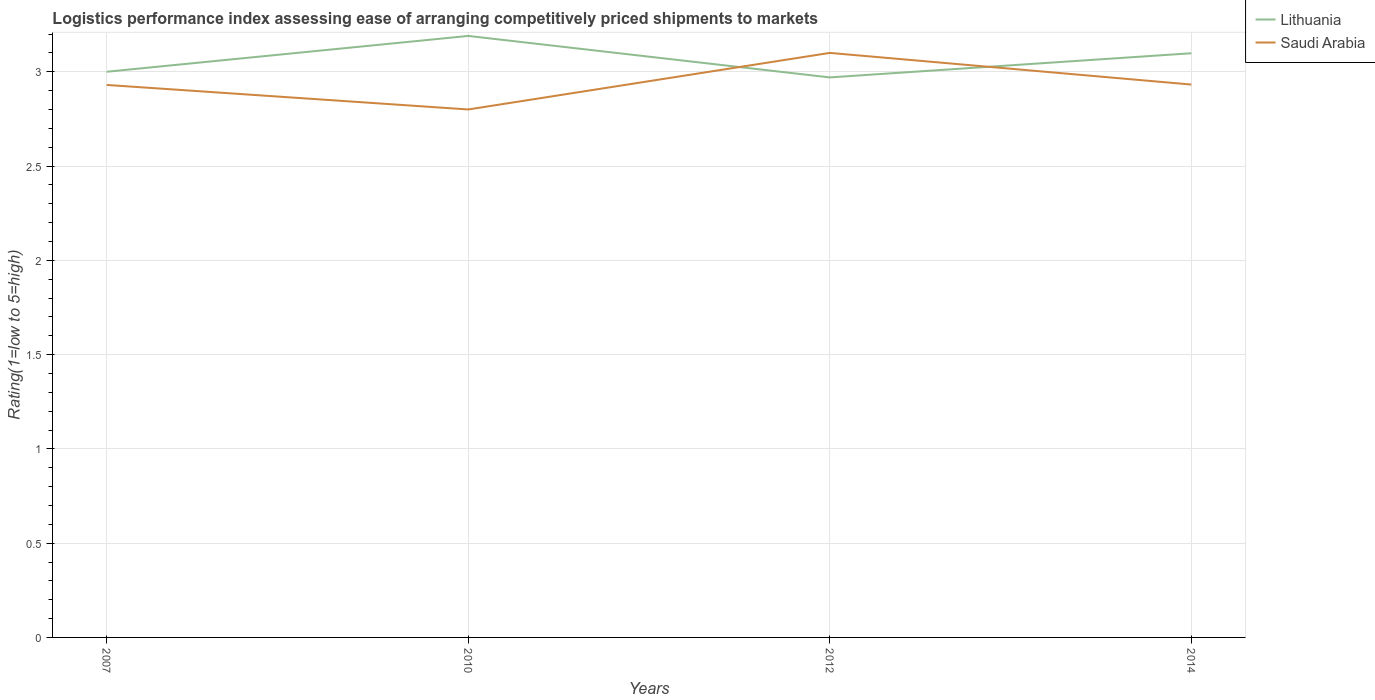In which year was the Logistic performance index in Lithuania maximum?
Offer a terse response. 2012. What is the total Logistic performance index in Saudi Arabia in the graph?
Offer a terse response. -0.17. What is the difference between the highest and the second highest Logistic performance index in Saudi Arabia?
Your answer should be compact. 0.3. Is the Logistic performance index in Lithuania strictly greater than the Logistic performance index in Saudi Arabia over the years?
Provide a short and direct response. No. How many years are there in the graph?
Ensure brevity in your answer.  4. What is the difference between two consecutive major ticks on the Y-axis?
Give a very brief answer. 0.5. Does the graph contain any zero values?
Provide a succinct answer. No. Where does the legend appear in the graph?
Your answer should be very brief. Top right. How many legend labels are there?
Your answer should be compact. 2. How are the legend labels stacked?
Provide a short and direct response. Vertical. What is the title of the graph?
Ensure brevity in your answer.  Logistics performance index assessing ease of arranging competitively priced shipments to markets. What is the label or title of the Y-axis?
Ensure brevity in your answer.  Rating(1=low to 5=high). What is the Rating(1=low to 5=high) in Lithuania in 2007?
Offer a terse response. 3. What is the Rating(1=low to 5=high) of Saudi Arabia in 2007?
Keep it short and to the point. 2.93. What is the Rating(1=low to 5=high) in Lithuania in 2010?
Your response must be concise. 3.19. What is the Rating(1=low to 5=high) in Saudi Arabia in 2010?
Your response must be concise. 2.8. What is the Rating(1=low to 5=high) in Lithuania in 2012?
Keep it short and to the point. 2.97. What is the Rating(1=low to 5=high) in Lithuania in 2014?
Provide a succinct answer. 3.1. What is the Rating(1=low to 5=high) of Saudi Arabia in 2014?
Provide a short and direct response. 2.93. Across all years, what is the maximum Rating(1=low to 5=high) of Lithuania?
Provide a succinct answer. 3.19. Across all years, what is the minimum Rating(1=low to 5=high) in Lithuania?
Your answer should be very brief. 2.97. Across all years, what is the minimum Rating(1=low to 5=high) of Saudi Arabia?
Keep it short and to the point. 2.8. What is the total Rating(1=low to 5=high) in Lithuania in the graph?
Offer a very short reply. 12.26. What is the total Rating(1=low to 5=high) in Saudi Arabia in the graph?
Offer a terse response. 11.76. What is the difference between the Rating(1=low to 5=high) of Lithuania in 2007 and that in 2010?
Your answer should be very brief. -0.19. What is the difference between the Rating(1=low to 5=high) of Saudi Arabia in 2007 and that in 2010?
Offer a terse response. 0.13. What is the difference between the Rating(1=low to 5=high) in Saudi Arabia in 2007 and that in 2012?
Provide a short and direct response. -0.17. What is the difference between the Rating(1=low to 5=high) in Lithuania in 2007 and that in 2014?
Offer a very short reply. -0.1. What is the difference between the Rating(1=low to 5=high) of Saudi Arabia in 2007 and that in 2014?
Your answer should be compact. -0. What is the difference between the Rating(1=low to 5=high) of Lithuania in 2010 and that in 2012?
Give a very brief answer. 0.22. What is the difference between the Rating(1=low to 5=high) in Saudi Arabia in 2010 and that in 2012?
Your response must be concise. -0.3. What is the difference between the Rating(1=low to 5=high) in Lithuania in 2010 and that in 2014?
Offer a terse response. 0.09. What is the difference between the Rating(1=low to 5=high) of Saudi Arabia in 2010 and that in 2014?
Offer a terse response. -0.13. What is the difference between the Rating(1=low to 5=high) in Lithuania in 2012 and that in 2014?
Your answer should be compact. -0.13. What is the difference between the Rating(1=low to 5=high) in Saudi Arabia in 2012 and that in 2014?
Offer a very short reply. 0.17. What is the difference between the Rating(1=low to 5=high) of Lithuania in 2007 and the Rating(1=low to 5=high) of Saudi Arabia in 2012?
Give a very brief answer. -0.1. What is the difference between the Rating(1=low to 5=high) of Lithuania in 2007 and the Rating(1=low to 5=high) of Saudi Arabia in 2014?
Offer a very short reply. 0.07. What is the difference between the Rating(1=low to 5=high) in Lithuania in 2010 and the Rating(1=low to 5=high) in Saudi Arabia in 2012?
Your response must be concise. 0.09. What is the difference between the Rating(1=low to 5=high) of Lithuania in 2010 and the Rating(1=low to 5=high) of Saudi Arabia in 2014?
Provide a short and direct response. 0.26. What is the difference between the Rating(1=low to 5=high) of Lithuania in 2012 and the Rating(1=low to 5=high) of Saudi Arabia in 2014?
Give a very brief answer. 0.04. What is the average Rating(1=low to 5=high) of Lithuania per year?
Your answer should be compact. 3.06. What is the average Rating(1=low to 5=high) of Saudi Arabia per year?
Your response must be concise. 2.94. In the year 2007, what is the difference between the Rating(1=low to 5=high) in Lithuania and Rating(1=low to 5=high) in Saudi Arabia?
Your response must be concise. 0.07. In the year 2010, what is the difference between the Rating(1=low to 5=high) of Lithuania and Rating(1=low to 5=high) of Saudi Arabia?
Your answer should be compact. 0.39. In the year 2012, what is the difference between the Rating(1=low to 5=high) in Lithuania and Rating(1=low to 5=high) in Saudi Arabia?
Provide a short and direct response. -0.13. In the year 2014, what is the difference between the Rating(1=low to 5=high) in Lithuania and Rating(1=low to 5=high) in Saudi Arabia?
Give a very brief answer. 0.17. What is the ratio of the Rating(1=low to 5=high) in Lithuania in 2007 to that in 2010?
Provide a succinct answer. 0.94. What is the ratio of the Rating(1=low to 5=high) of Saudi Arabia in 2007 to that in 2010?
Provide a short and direct response. 1.05. What is the ratio of the Rating(1=low to 5=high) of Saudi Arabia in 2007 to that in 2012?
Offer a very short reply. 0.95. What is the ratio of the Rating(1=low to 5=high) of Lithuania in 2007 to that in 2014?
Your response must be concise. 0.97. What is the ratio of the Rating(1=low to 5=high) in Saudi Arabia in 2007 to that in 2014?
Give a very brief answer. 1. What is the ratio of the Rating(1=low to 5=high) of Lithuania in 2010 to that in 2012?
Offer a terse response. 1.07. What is the ratio of the Rating(1=low to 5=high) of Saudi Arabia in 2010 to that in 2012?
Keep it short and to the point. 0.9. What is the ratio of the Rating(1=low to 5=high) of Lithuania in 2010 to that in 2014?
Make the answer very short. 1.03. What is the ratio of the Rating(1=low to 5=high) of Saudi Arabia in 2010 to that in 2014?
Ensure brevity in your answer.  0.95. What is the ratio of the Rating(1=low to 5=high) of Lithuania in 2012 to that in 2014?
Ensure brevity in your answer.  0.96. What is the ratio of the Rating(1=low to 5=high) of Saudi Arabia in 2012 to that in 2014?
Make the answer very short. 1.06. What is the difference between the highest and the second highest Rating(1=low to 5=high) in Lithuania?
Provide a succinct answer. 0.09. What is the difference between the highest and the second highest Rating(1=low to 5=high) of Saudi Arabia?
Provide a succinct answer. 0.17. What is the difference between the highest and the lowest Rating(1=low to 5=high) in Lithuania?
Your answer should be compact. 0.22. 